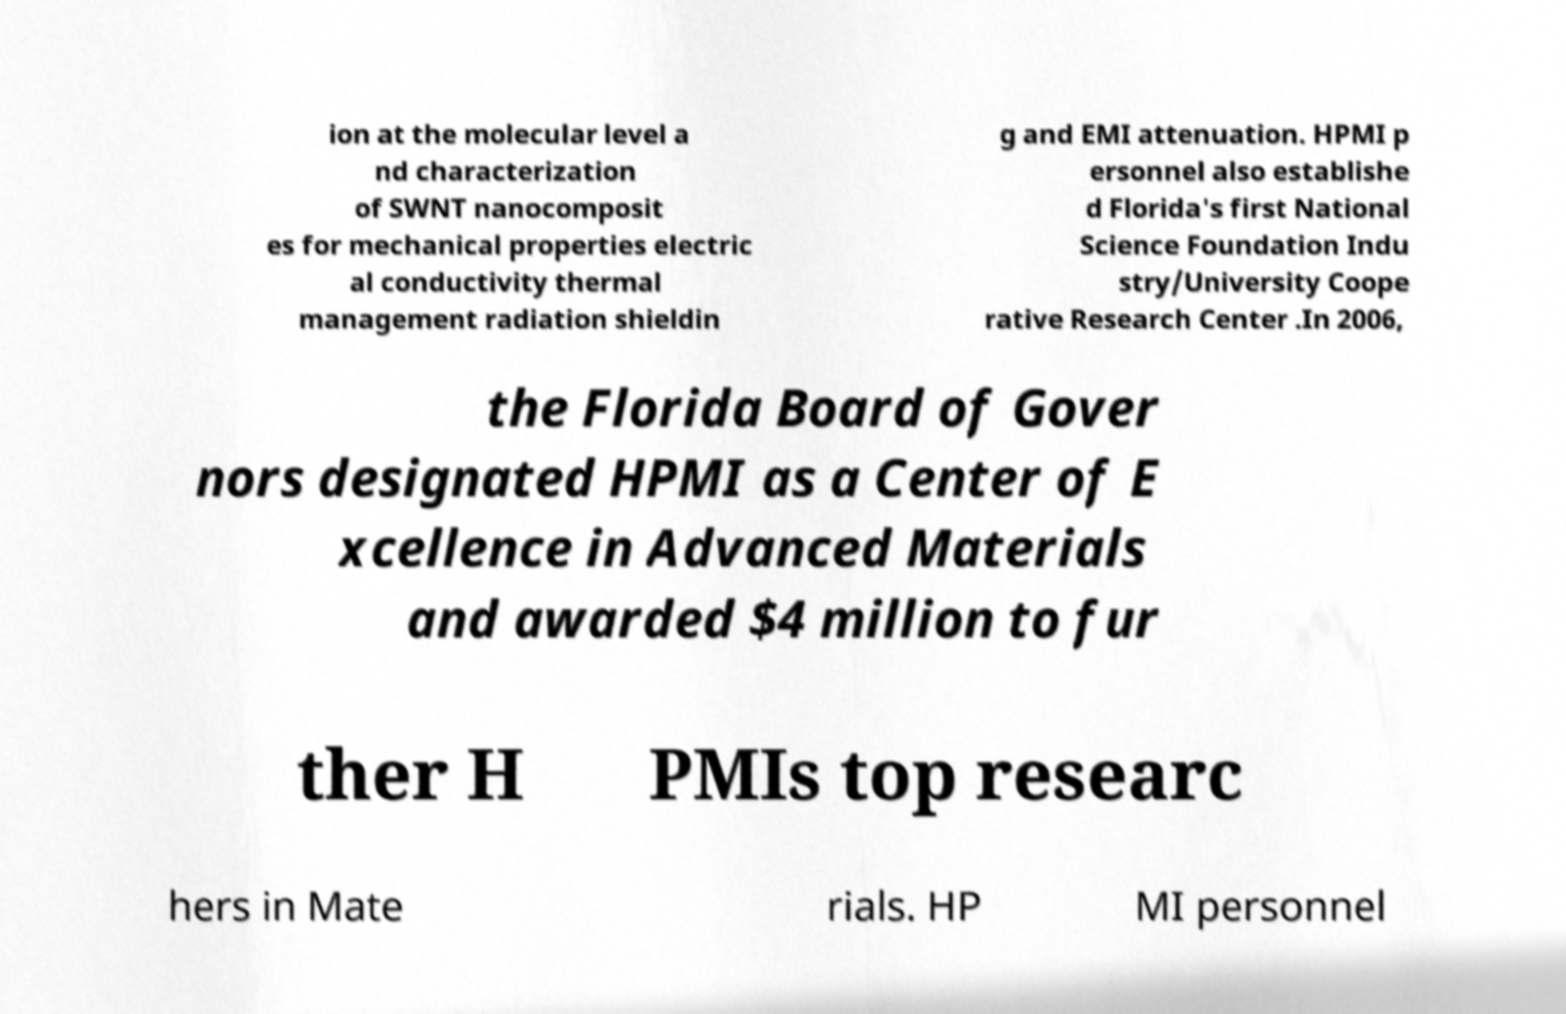For documentation purposes, I need the text within this image transcribed. Could you provide that? ion at the molecular level a nd characterization of SWNT nanocomposit es for mechanical properties electric al conductivity thermal management radiation shieldin g and EMI attenuation. HPMI p ersonnel also establishe d Florida's first National Science Foundation Indu stry/University Coope rative Research Center .In 2006, the Florida Board of Gover nors designated HPMI as a Center of E xcellence in Advanced Materials and awarded $4 million to fur ther H PMIs top researc hers in Mate rials. HP MI personnel 